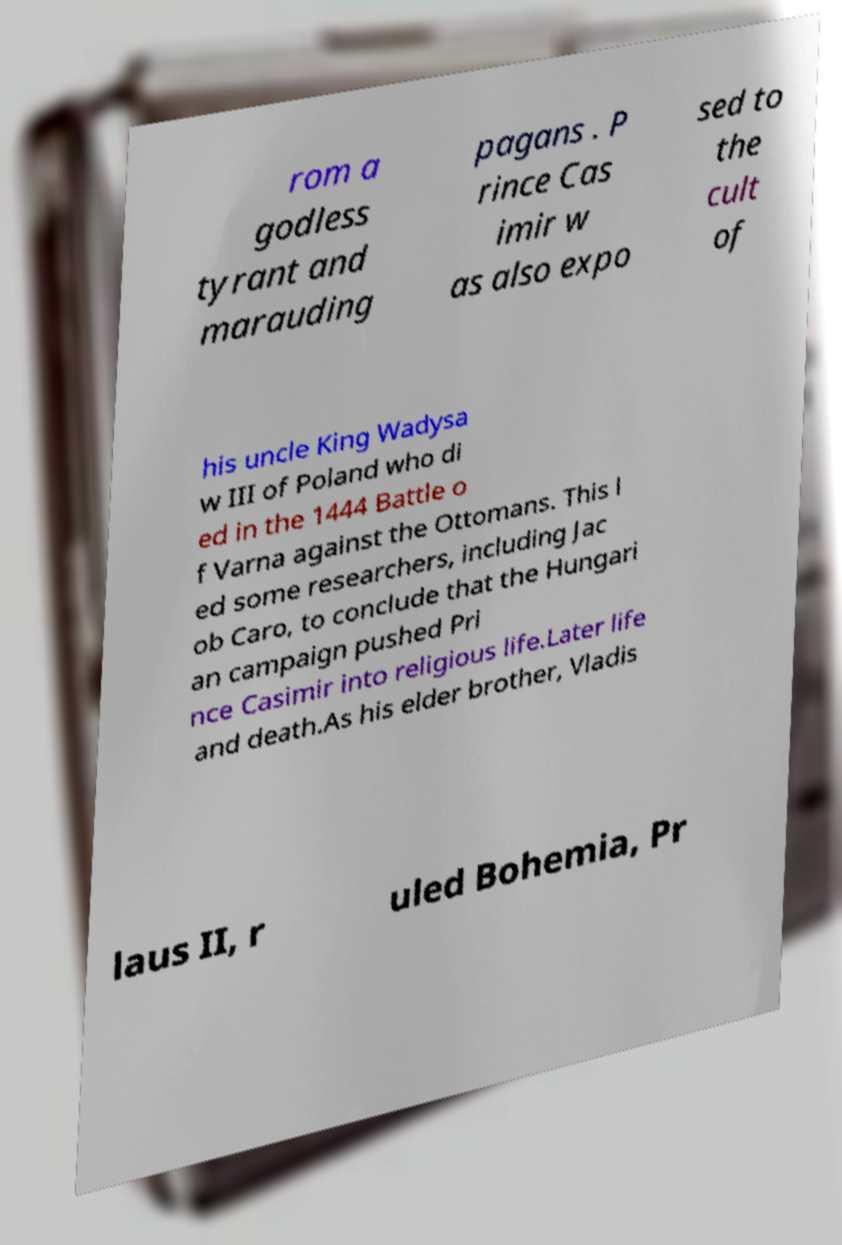Could you assist in decoding the text presented in this image and type it out clearly? rom a godless tyrant and marauding pagans . P rince Cas imir w as also expo sed to the cult of his uncle King Wadysa w III of Poland who di ed in the 1444 Battle o f Varna against the Ottomans. This l ed some researchers, including Jac ob Caro, to conclude that the Hungari an campaign pushed Pri nce Casimir into religious life.Later life and death.As his elder brother, Vladis laus II, r uled Bohemia, Pr 